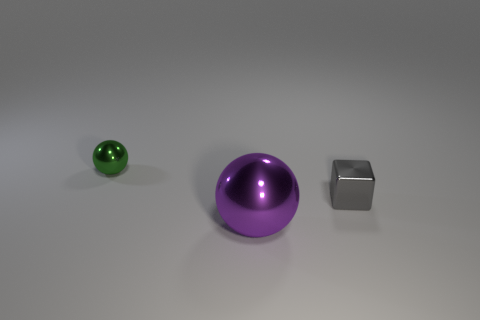Add 2 brown rubber blocks. How many objects exist? 5 Add 3 purple objects. How many purple objects are left? 4 Add 3 large shiny spheres. How many large shiny spheres exist? 4 Subtract 0 brown blocks. How many objects are left? 3 Subtract all cubes. How many objects are left? 2 Subtract all metallic things. Subtract all blue cylinders. How many objects are left? 0 